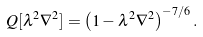<formula> <loc_0><loc_0><loc_500><loc_500>Q [ \lambda ^ { 2 } \nabla ^ { 2 } ] = \left ( 1 - \lambda ^ { 2 } \nabla ^ { 2 } \right ) ^ { - 7 / 6 } .</formula> 